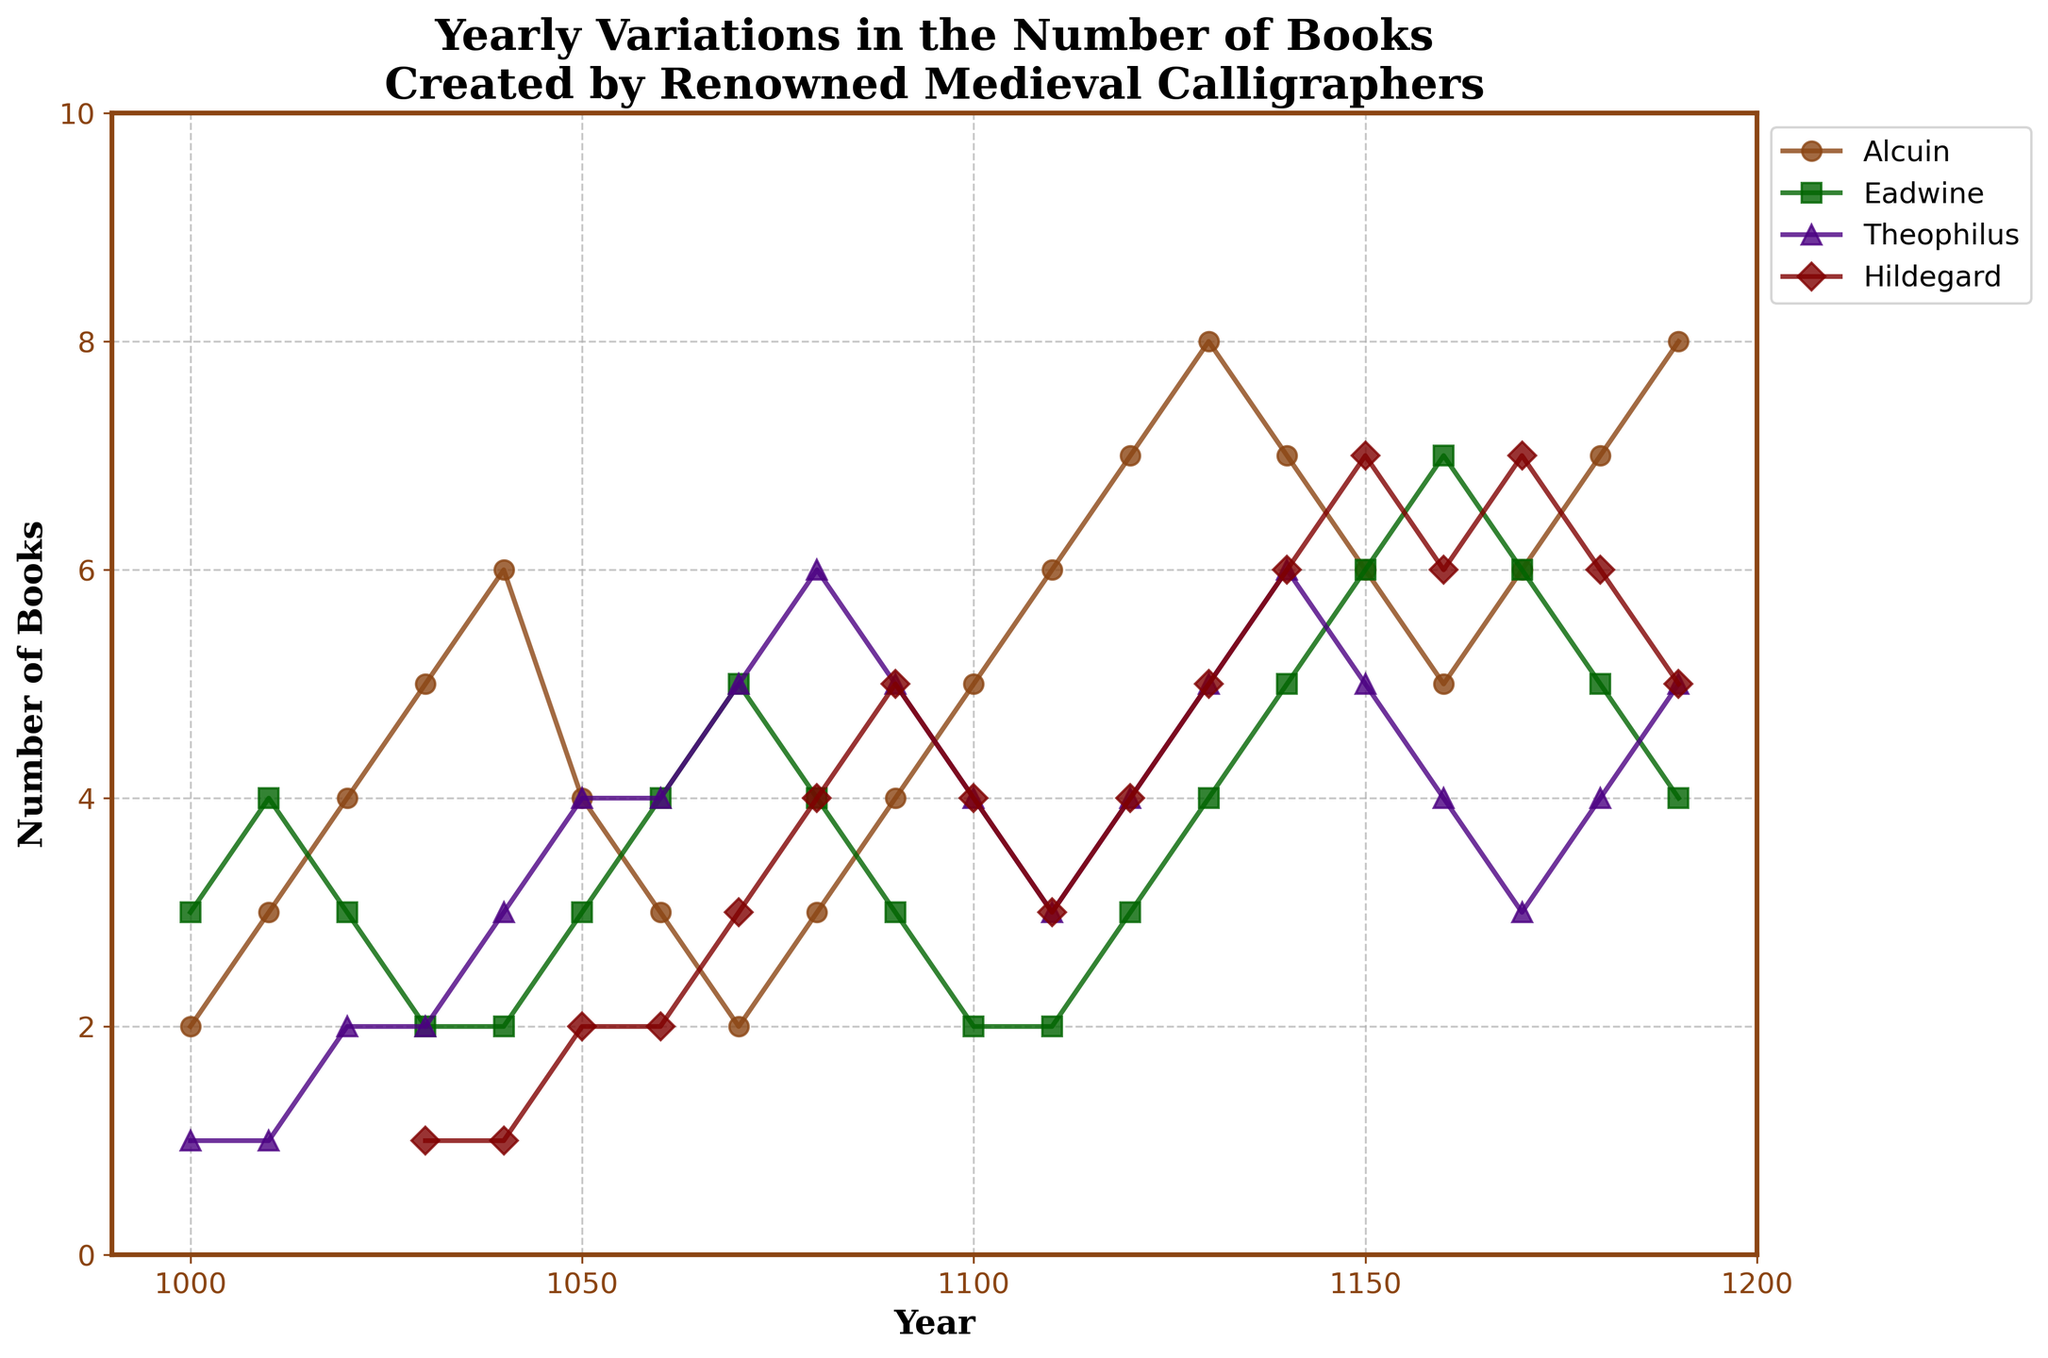What is the time range covered by the figure? The x-axis of the plot covers years from 1000 to 1190, as indicated by the tick marks and labels on the x-axis.
Answer: 1000 to 1190 How many distinct calligraphers are shown on the plot? There are four different colored lines in the plot, each labeled with a calligrapher's name in the legend: Alcuin, Eadwine, Theophilus, and Hildegard.
Answer: Four Which calligrapher created the most books in the year 1140? In 1140, the plot shows four data points, with Hildegard's line (maroon color) reaching the highest value, at 6 books.
Answer: Hildegard During which year did Theophilus create exactly 6 books? The data point for Theophilus (indigo color) reaches 6 books in the year 1080, as indicated by the plotted value on the line.
Answer: 1080 What is the average number of books created by Alcuin in the first fifty years (1000-1050)? Sum the number of books created by Alcuin from year 1000 to 1050. (2+3+4+5+6+4=24). Then divide by the number of data points (6). So the average is 24/6 = 4.
Answer: 4 In which year did Eadwine's production surpass Alcuin's? By comparing the data points of Eadwine (green) and Alcuin (brown) across the years, it is evident that Eadwine's line surpasses Alcuin's in 1070, where Eadwine created 5 books compared to Alcuin's 2.
Answer: 1070 Which calligrapher showed the most consistent (least variation in) production over the entire period? By visually inspecting the plot, Eadwine's line (green) varies the least compared to the other calligraphers, showing minor fluctuations throughout the years.
Answer: Eadwine In which decade did Hildegard experience the highest increase in book creation? By analyzing the slope changes of Hildegard's line (maroon), the largest increase appears between the years 1140 to 1150, where her production increased from 6 to 7 books.
Answer: 1140 to 1150 What is the total number of books created by Theophilus in the final century (1090-1190)? Sum the number of books created by Theophilus from year 1090 to 1190. (5+4+3+4+5+6+5+4+3+4+5=48). So the total is 48 books.
Answer: 48 